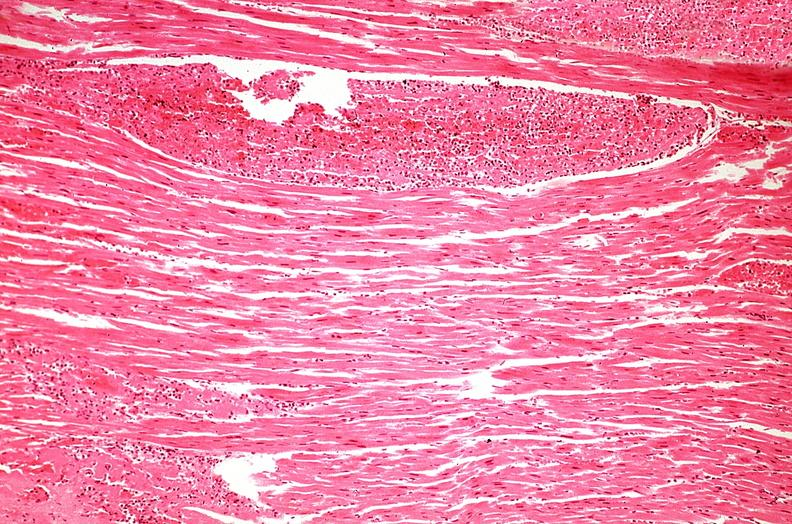where is this from?
Answer the question using a single word or phrase. Heart 